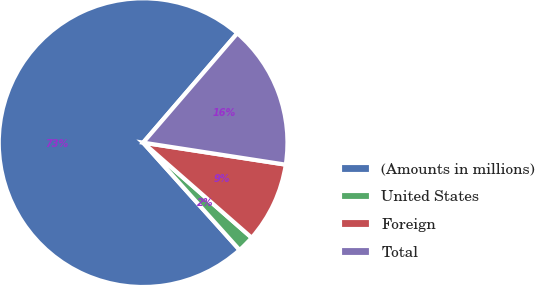<chart> <loc_0><loc_0><loc_500><loc_500><pie_chart><fcel>(Amounts in millions)<fcel>United States<fcel>Foreign<fcel>Total<nl><fcel>72.97%<fcel>1.9%<fcel>9.01%<fcel>16.12%<nl></chart> 